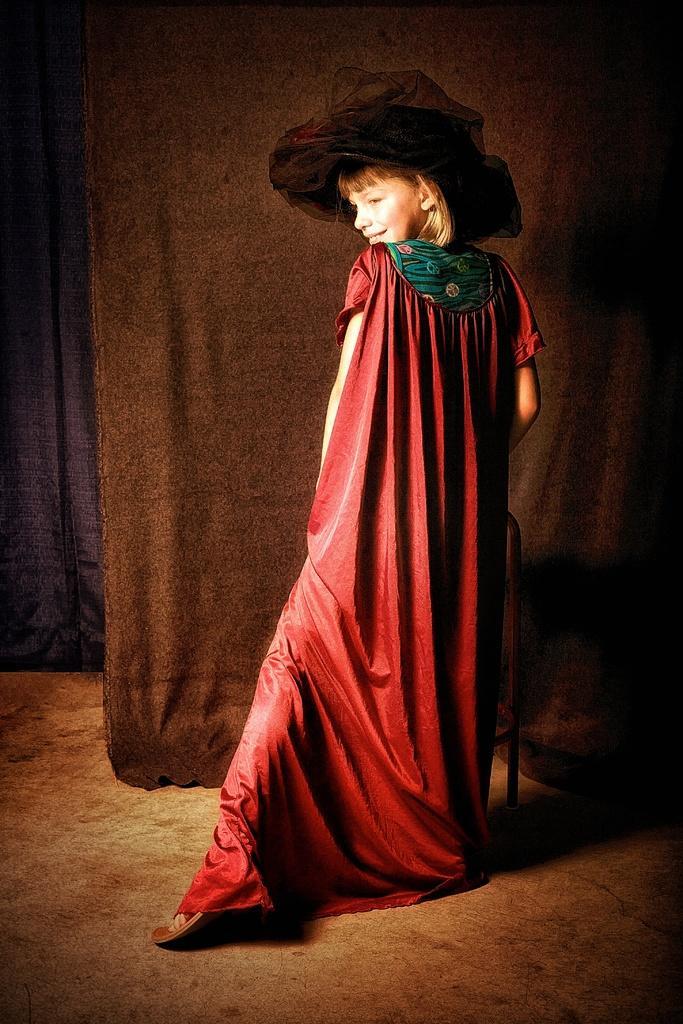Can you describe this image briefly? A girl is standing wearing a red dress and a black hat. There is a chair and curtains behind her. 